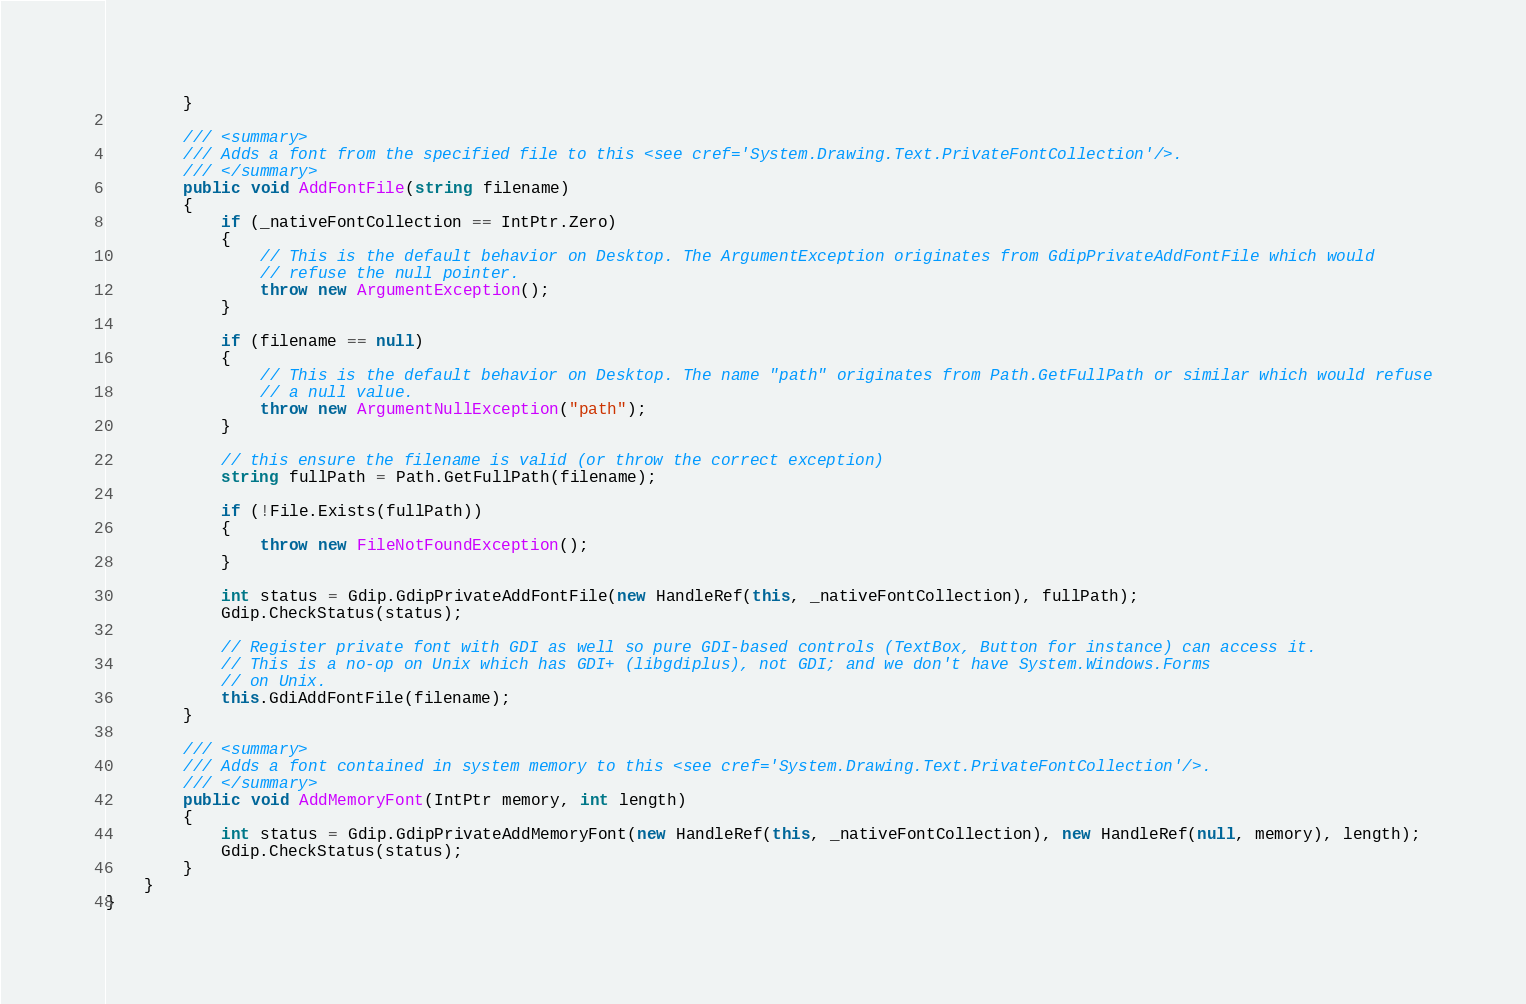<code> <loc_0><loc_0><loc_500><loc_500><_C#_>        }

        /// <summary>
        /// Adds a font from the specified file to this <see cref='System.Drawing.Text.PrivateFontCollection'/>.
        /// </summary>
        public void AddFontFile(string filename)
        {
            if (_nativeFontCollection == IntPtr.Zero)
            {
                // This is the default behavior on Desktop. The ArgumentException originates from GdipPrivateAddFontFile which would
                // refuse the null pointer.
                throw new ArgumentException();
            }

            if (filename == null)
            {
                // This is the default behavior on Desktop. The name "path" originates from Path.GetFullPath or similar which would refuse
                // a null value.
                throw new ArgumentNullException("path");
            }

            // this ensure the filename is valid (or throw the correct exception)
            string fullPath = Path.GetFullPath(filename);

            if (!File.Exists(fullPath))
            {
                throw new FileNotFoundException();
            }

            int status = Gdip.GdipPrivateAddFontFile(new HandleRef(this, _nativeFontCollection), fullPath);
            Gdip.CheckStatus(status);

            // Register private font with GDI as well so pure GDI-based controls (TextBox, Button for instance) can access it.
            // This is a no-op on Unix which has GDI+ (libgdiplus), not GDI; and we don't have System.Windows.Forms
            // on Unix.
            this.GdiAddFontFile(filename);
        }

        /// <summary>
        /// Adds a font contained in system memory to this <see cref='System.Drawing.Text.PrivateFontCollection'/>.
        /// </summary>
        public void AddMemoryFont(IntPtr memory, int length)
        {
            int status = Gdip.GdipPrivateAddMemoryFont(new HandleRef(this, _nativeFontCollection), new HandleRef(null, memory), length);
            Gdip.CheckStatus(status);
        }
    }
}
</code> 